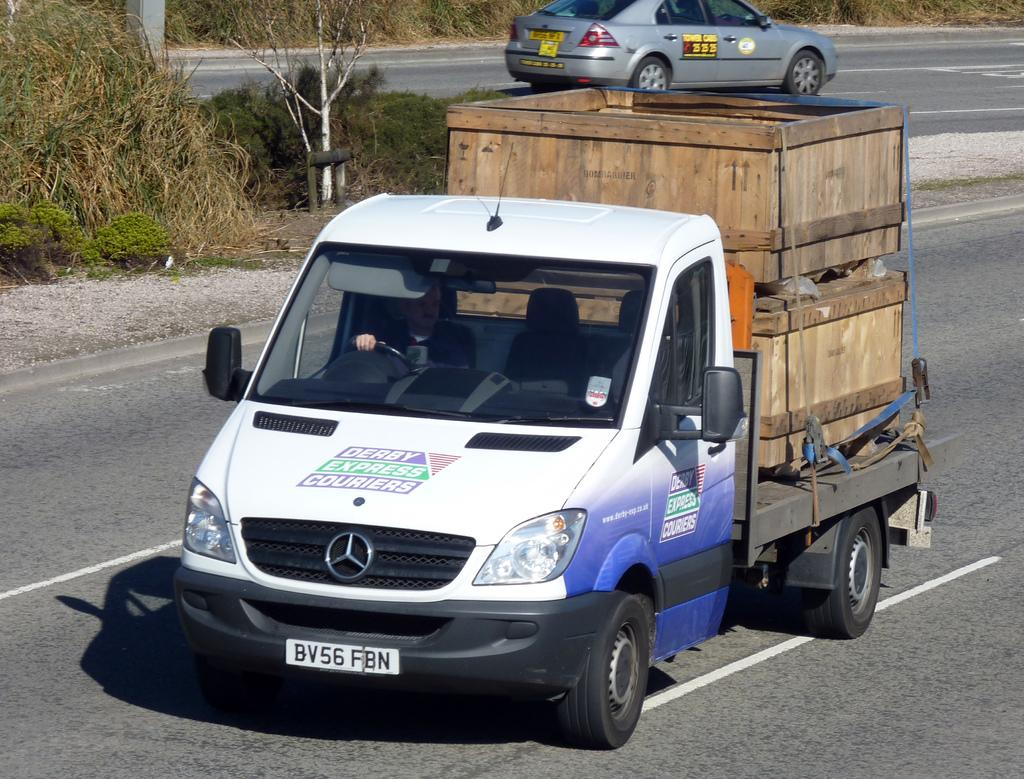<image>
Give a short and clear explanation of the subsequent image. A van with Derby Express Couriers written on it and two wooden crates on the back. 